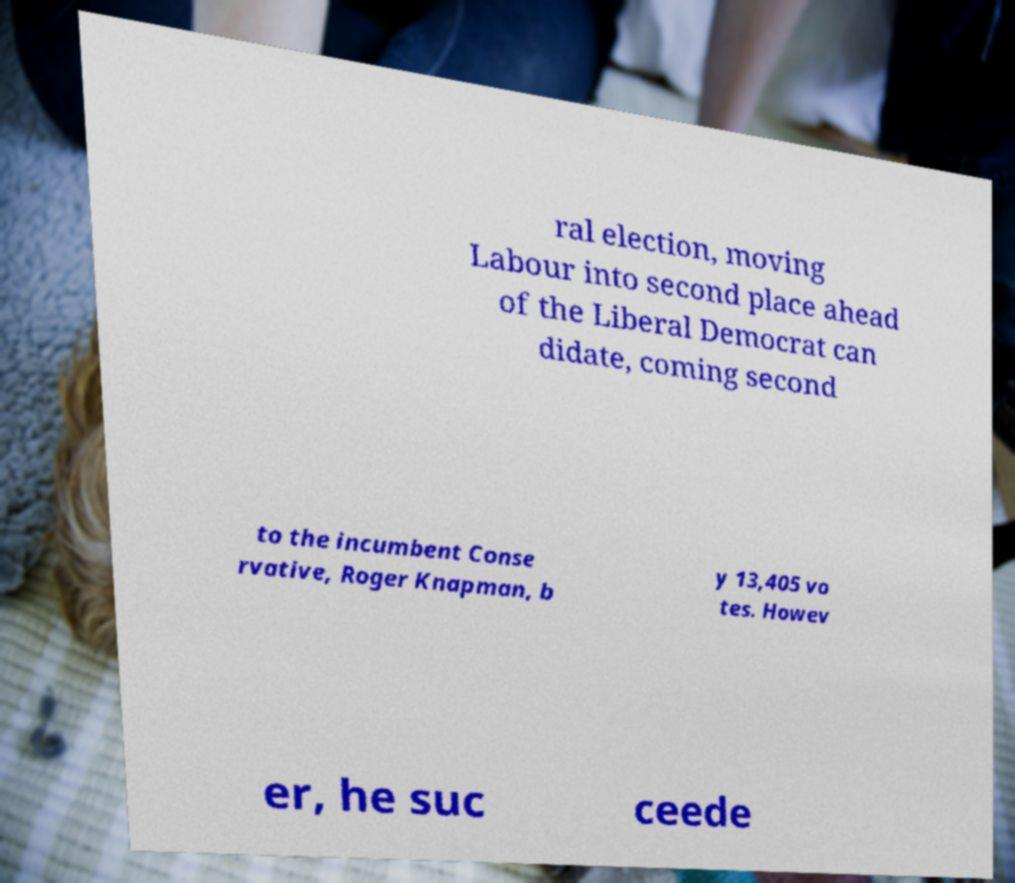Can you accurately transcribe the text from the provided image for me? ral election, moving Labour into second place ahead of the Liberal Democrat can didate, coming second to the incumbent Conse rvative, Roger Knapman, b y 13,405 vo tes. Howev er, he suc ceede 